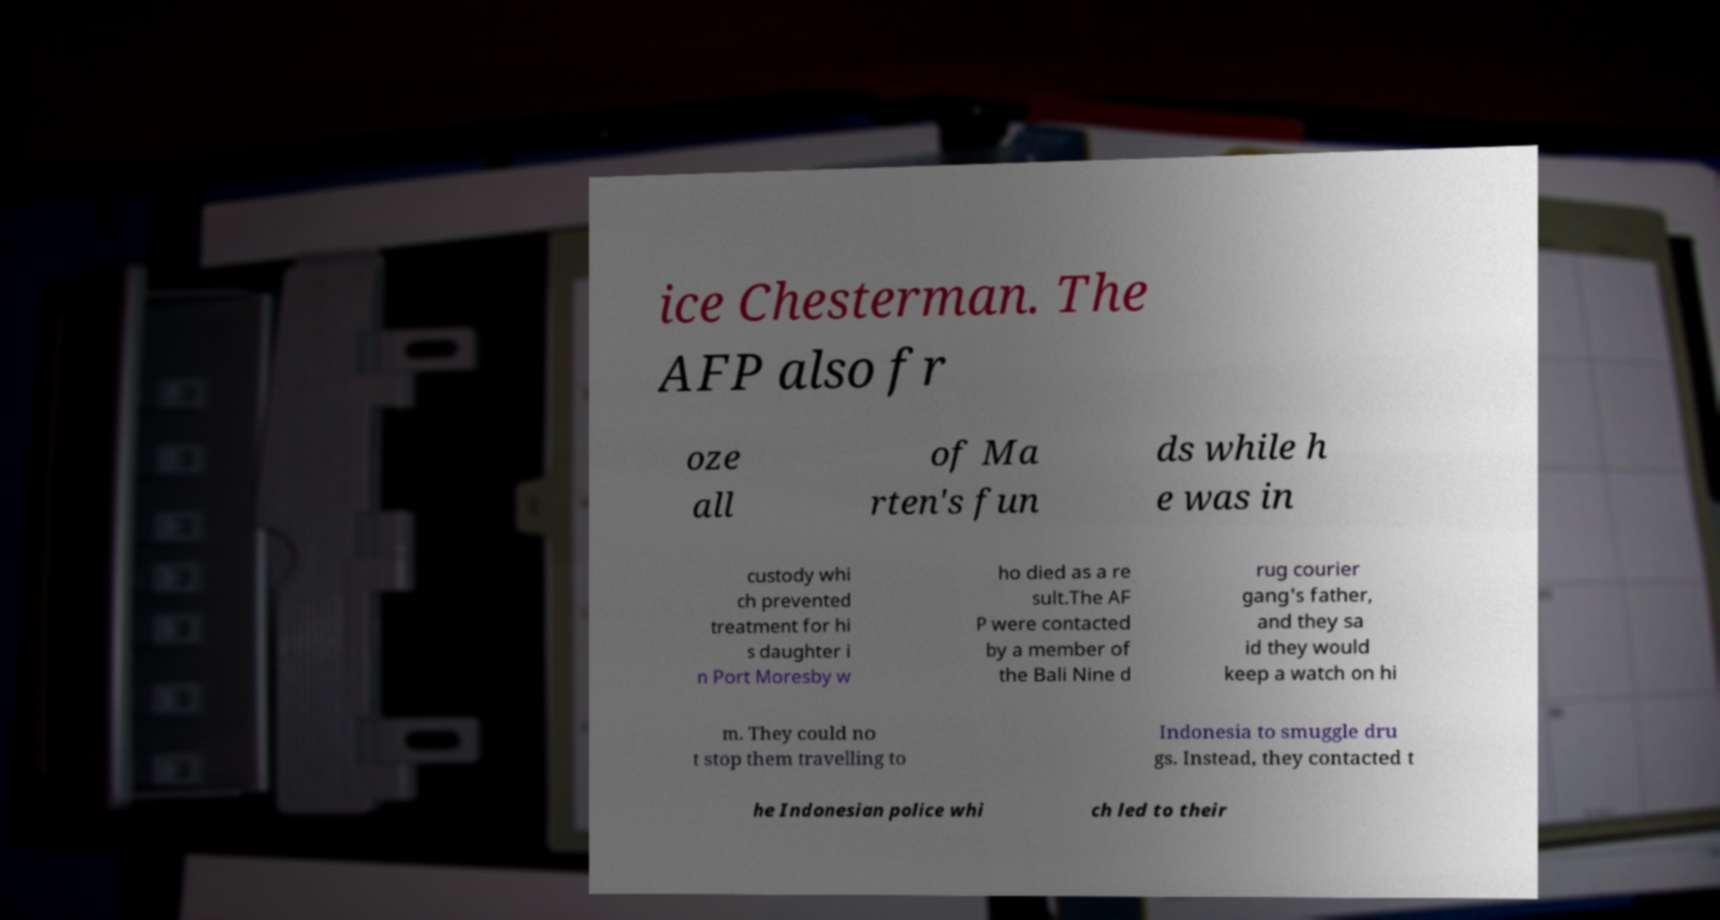There's text embedded in this image that I need extracted. Can you transcribe it verbatim? ice Chesterman. The AFP also fr oze all of Ma rten's fun ds while h e was in custody whi ch prevented treatment for hi s daughter i n Port Moresby w ho died as a re sult.The AF P were contacted by a member of the Bali Nine d rug courier gang's father, and they sa id they would keep a watch on hi m. They could no t stop them travelling to Indonesia to smuggle dru gs. Instead, they contacted t he Indonesian police whi ch led to their 